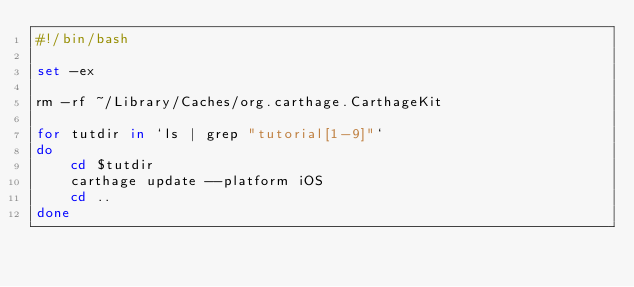<code> <loc_0><loc_0><loc_500><loc_500><_Bash_>#!/bin/bash

set -ex

rm -rf ~/Library/Caches/org.carthage.CarthageKit

for tutdir in `ls | grep "tutorial[1-9]"`
do
    cd $tutdir
    carthage update --platform iOS
    cd ..
done
</code> 